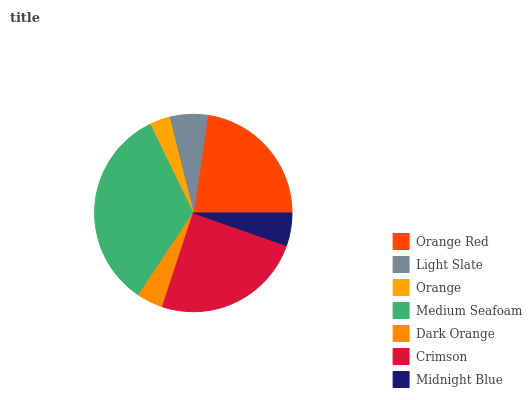Is Orange the minimum?
Answer yes or no. Yes. Is Medium Seafoam the maximum?
Answer yes or no. Yes. Is Light Slate the minimum?
Answer yes or no. No. Is Light Slate the maximum?
Answer yes or no. No. Is Orange Red greater than Light Slate?
Answer yes or no. Yes. Is Light Slate less than Orange Red?
Answer yes or no. Yes. Is Light Slate greater than Orange Red?
Answer yes or no. No. Is Orange Red less than Light Slate?
Answer yes or no. No. Is Light Slate the high median?
Answer yes or no. Yes. Is Light Slate the low median?
Answer yes or no. Yes. Is Midnight Blue the high median?
Answer yes or no. No. Is Medium Seafoam the low median?
Answer yes or no. No. 